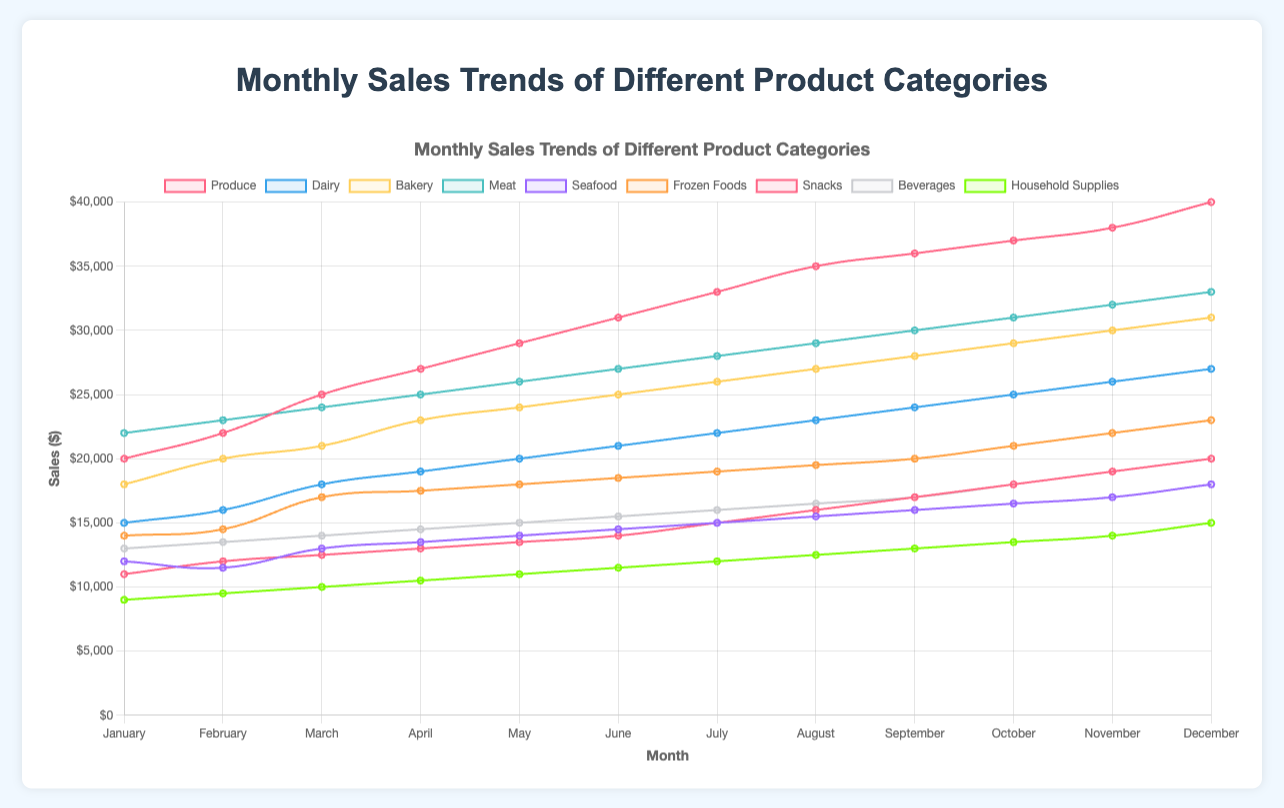What is the trend in sales of Produce over the months? The trend shows a steady increase in sales for the Produce category from January to December. For example, sales start at $20000 in January and rise gradually each month, reaching $40000 in December.
Answer: Steady increase Which product category had the highest sales in December? By observing the sales values for December, we can see that Produce has the highest sales at $40000.
Answer: Produce By how much did Meat sales increase from January to December? Sales for Meat in January were $22000, and in December they were $33000. The increase is calculated as $33000 - $22000 = $11000.
Answer: $11000 Which category showed the least growth in sales from January to December? We calculate the difference in sales for each category from January to December. Household Supplies start with $9000 and end with $15000 showing an increase of $6000, which is the lowest among all categories.
Answer: Household Supplies During which month did Frozen Foods show the sharpest increase in sales? Comparing the monthly increase, the biggest jump for Frozen Foods is from September ($20000) to October ($21000), showing an increase of $1000.
Answer: October Which categories had sales under $20000 in January? By looking at the January sales values, categories with sales under $20000 are Seafood, Frozen Foods, Snacks, Beverages, and Household Supplies.
Answer: Seafood, Frozen Foods, Snacks, Beverages, Household Supplies How did Dairy sales in March compare to Bakery sales in the same month? In March, Dairy sales were $18000, while Bakery sales were $21000. Bakery sales were higher by $3000.
Answer: Bakery sales were higher What was the average sales figure for Beverages over the year? Summing the monthly sales for Beverages: $13000 + $13500 + $14000 + $14500 + $15000 + $15500 + $16000 + $16500 + $17000 + $18000 + $19000 + $20000 = $202000. Dividing by 12 (months), the average is $202000 / 12 = $16833.33.
Answer: $16833.33 From which month did Snacks see a noticeable improvement in sales? Starting from January ($11000) to February ($12000), the increase becomes more noticeable in March with a value of $12500, continuing steadily upwards each month.
Answer: March Does the Seafood category ever surpass the Beverages category in sales during the year? Comparing the monthly sales side by side, the Seafood category never surpasses the Beverages category at any point during the year.
Answer: No 